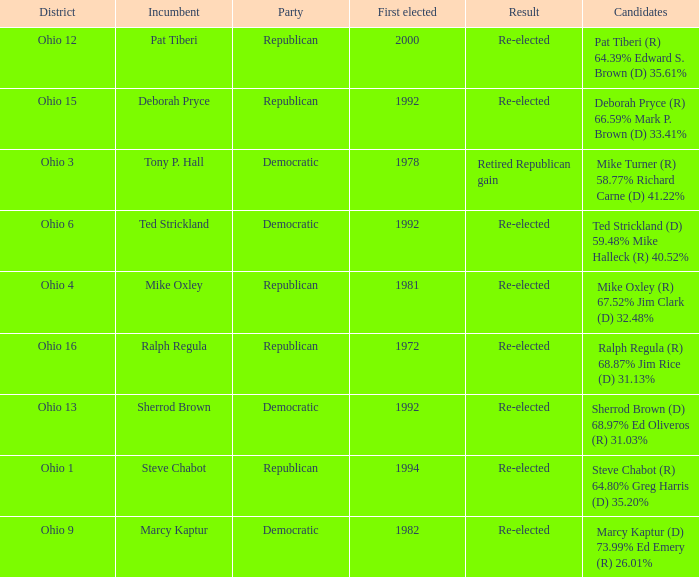Incumbent Deborah Pryce was a member of what party?  Republican. 